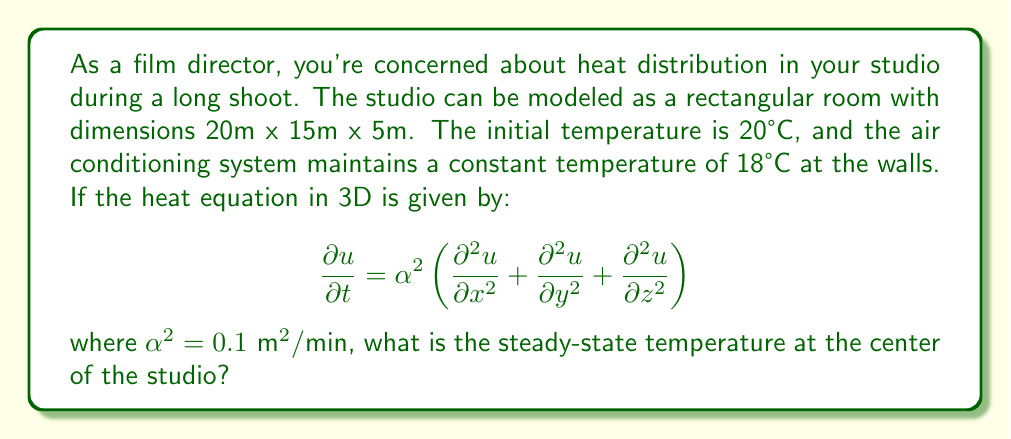Provide a solution to this math problem. To solve this problem, we need to follow these steps:

1) For the steady-state solution, the temperature doesn't change with time, so $\frac{\partial u}{\partial t} = 0$. This reduces our equation to:

   $$0 = \frac{\partial^2 u}{\partial x^2} + \frac{\partial^2 u}{\partial y^2} + \frac{\partial^2 u}{\partial z^2}$$

2) Given the symmetry of the problem, we can assume the solution has the form:

   $$u(x,y,z) = X(x)Y(y)Z(z)$$

3) Substituting this into our equation and separating variables, we get:

   $$\frac{X''}{X} + \frac{Y''}{Y} + \frac{Z''}{Z} = 0$$

4) Each term must be constant, let's say $-\lambda^2$, $-\mu^2$, and $-\nu^2$ respectively. This gives us:

   $$X'' + \lambda^2 X = 0, \quad Y'' + \mu^2 Y = 0, \quad Z'' + \nu^2 Z = 0$$

5) The general solutions are:

   $$X = A \cos(\lambda x) + B \sin(\lambda x)$$
   $$Y = C \cos(\mu y) + D \sin(\mu y)$$
   $$Z = E \cos(\nu z) + F \sin(\nu z)$$

6) Given the boundary conditions (18°C at the walls), we have:

   $$X(0) = X(20) = 18, \quad Y(0) = Y(15) = 18, \quad Z(0) = Z(5) = 18$$

7) This leads to:

   $$X = 18 \cos(\frac{n\pi x}{20}), \quad Y = 18 \cos(\frac{m\pi y}{15}), \quad Z = 18 \cos(\frac{k\pi z}{5})$$

   where $n$, $m$, and $k$ are odd integers.

8) The full solution is the sum of all possible combinations:

   $$u(x,y,z) = 18 + \sum_{n,m,k \text{ odd}} A_{nmk} \cos(\frac{n\pi x}{20}) \cos(\frac{m\pi y}{15}) \cos(\frac{k\pi z}{5})$$

9) At the center of the studio $(x,y,z) = (10,7.5,2.5)$, all cosine terms equal 1 for $n=m=k=1$, and approach 0 for higher odd integers.

10) Therefore, the steady-state temperature at the center is approximately:

    $$u(10,7.5,2.5) \approx 18 + A_{111}$$

11) $A_{111}$ can be determined from the initial condition, but it's small compared to 18. So, the temperature at the center will be slightly above 18°C.
Answer: Slightly above 18°C 